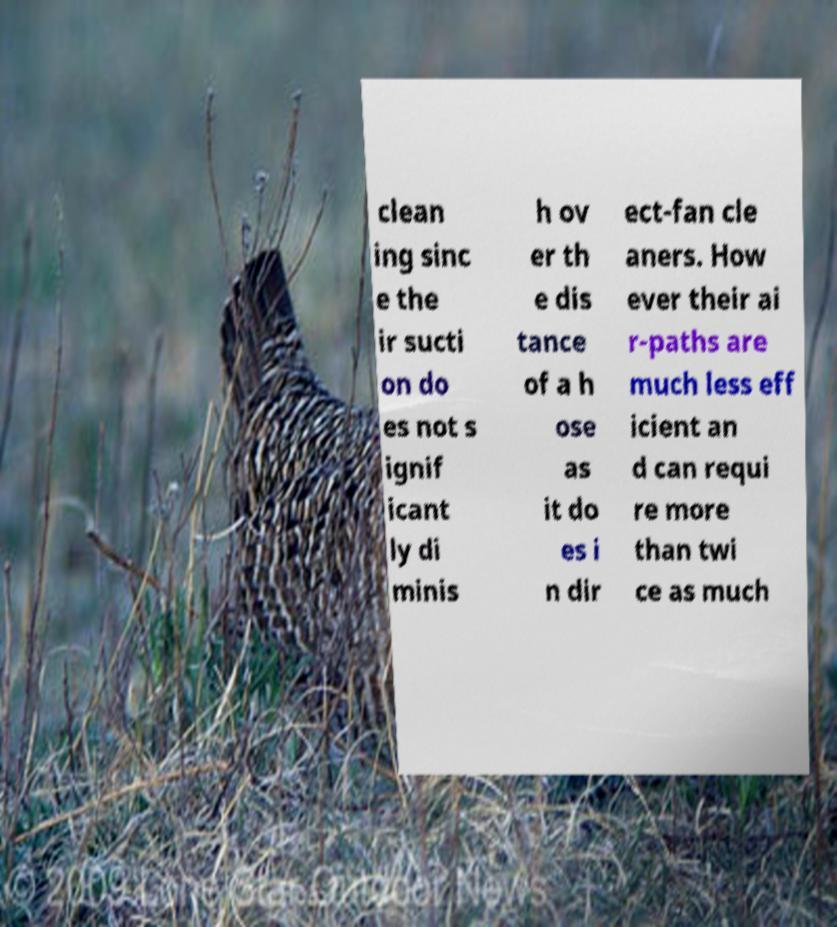For documentation purposes, I need the text within this image transcribed. Could you provide that? clean ing sinc e the ir sucti on do es not s ignif icant ly di minis h ov er th e dis tance of a h ose as it do es i n dir ect-fan cle aners. How ever their ai r-paths are much less eff icient an d can requi re more than twi ce as much 